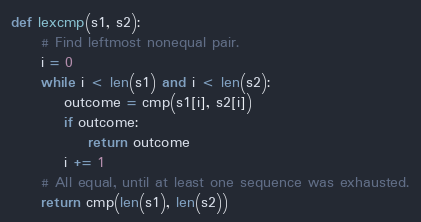<code> <loc_0><loc_0><loc_500><loc_500><_Python_>def lexcmp(s1, s2):
     # Find leftmost nonequal pair.
     i = 0
     while i < len(s1) and i < len(s2):
         outcome = cmp(s1[i], s2[i])
         if outcome:
             return outcome
         i += 1
     # All equal, until at least one sequence was exhausted.
     return cmp(len(s1), len(s2))
</code> 